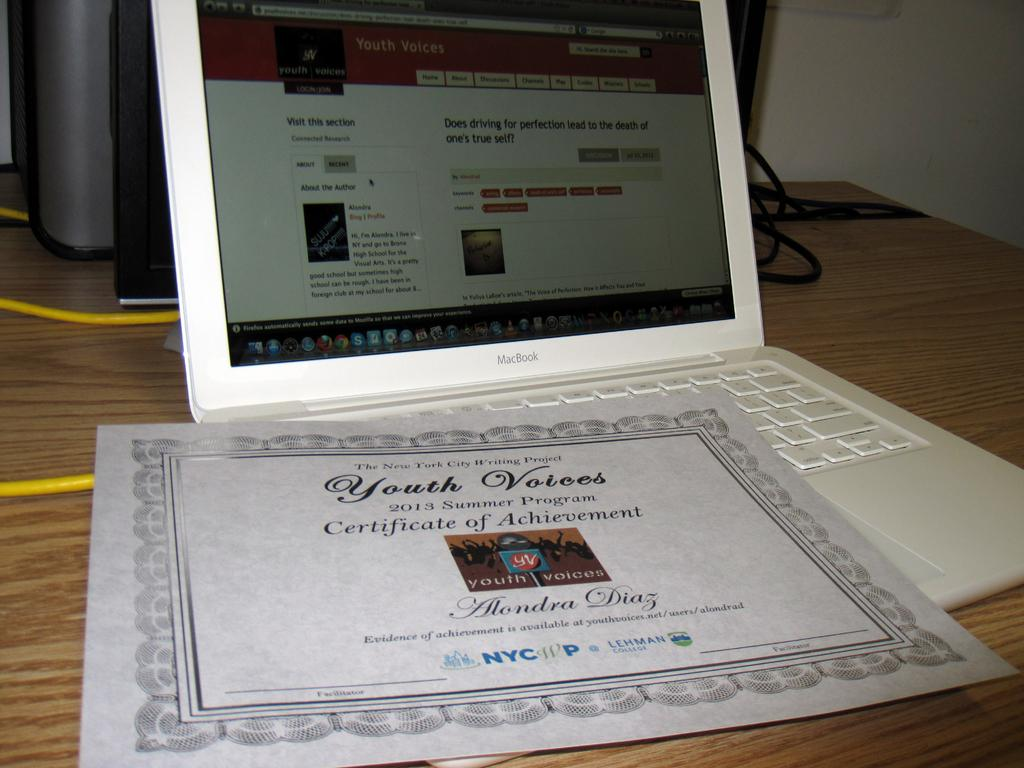<image>
Give a short and clear explanation of the subsequent image. a certificate on a laptop that says 'youth votees' 